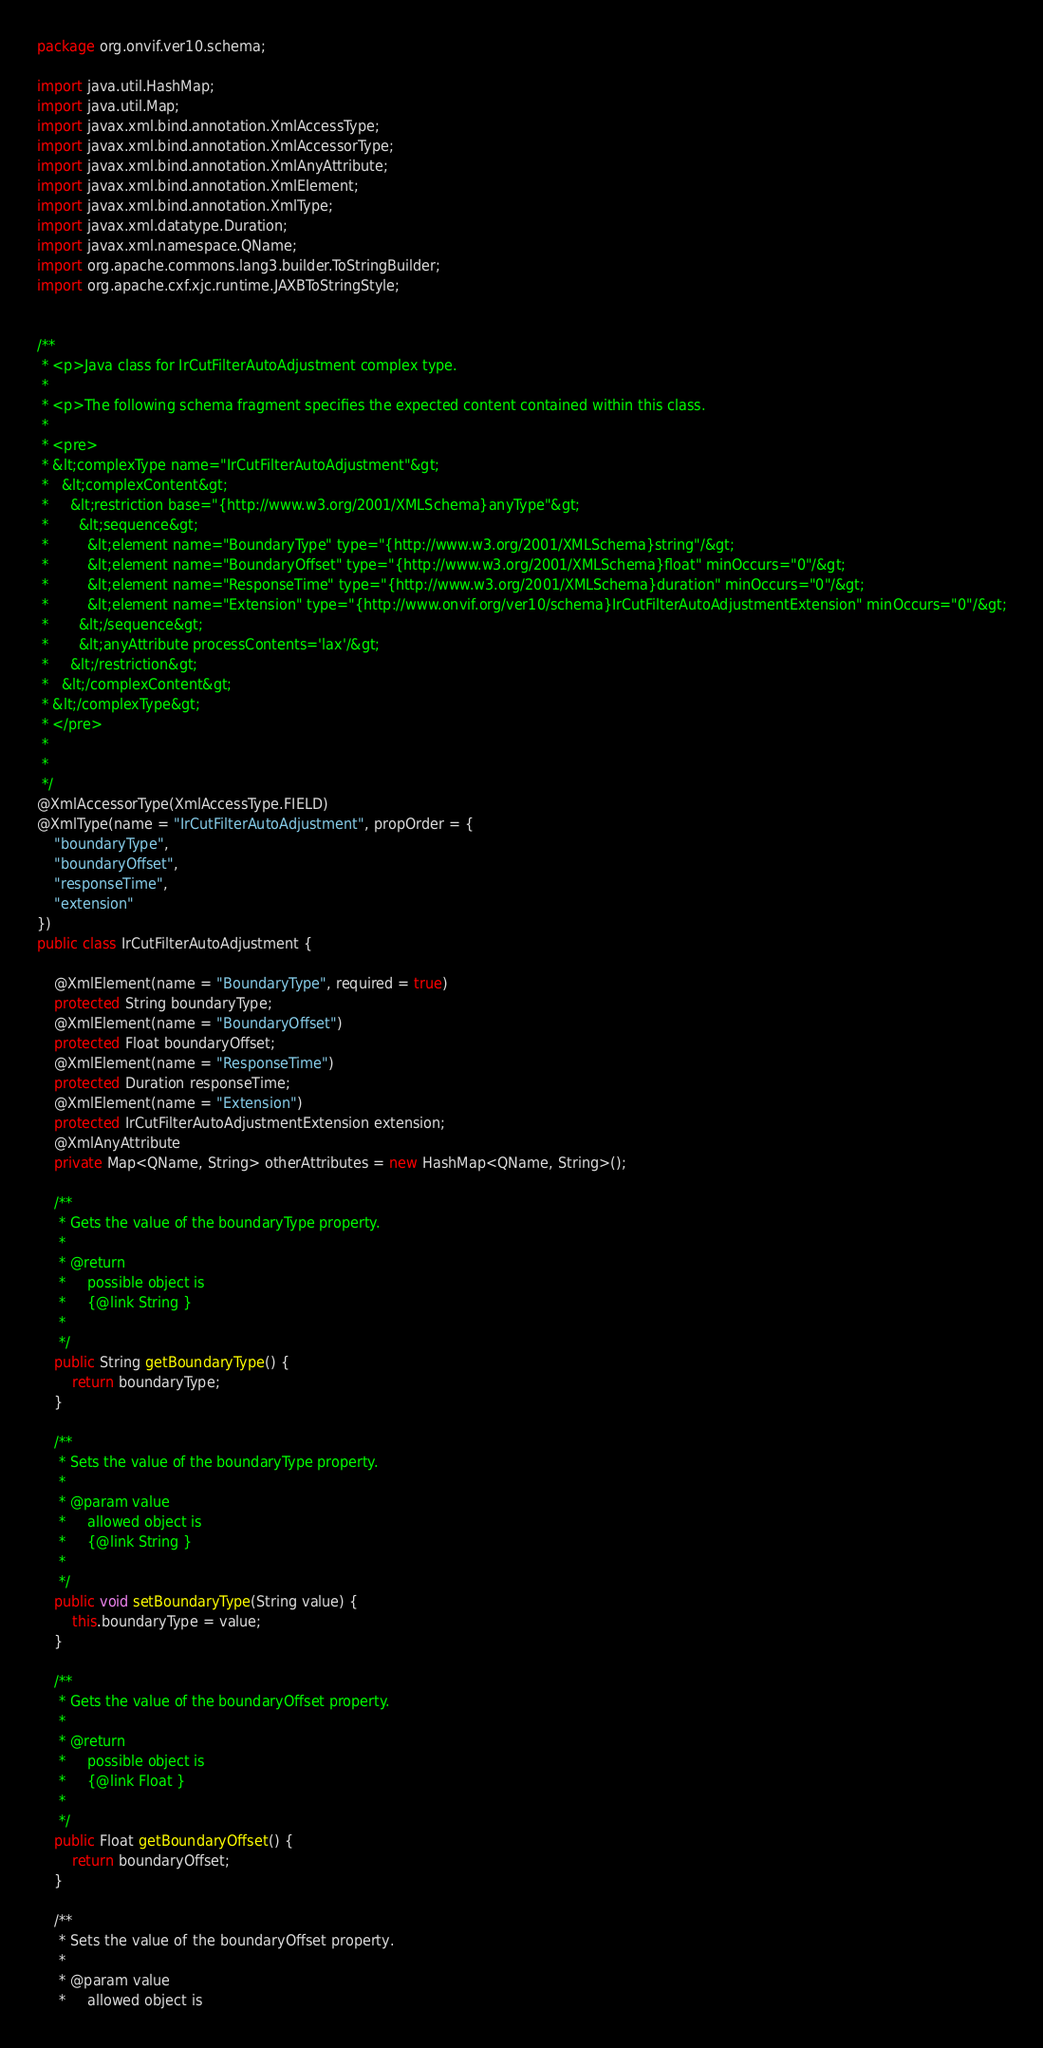<code> <loc_0><loc_0><loc_500><loc_500><_Java_>
package org.onvif.ver10.schema;

import java.util.HashMap;
import java.util.Map;
import javax.xml.bind.annotation.XmlAccessType;
import javax.xml.bind.annotation.XmlAccessorType;
import javax.xml.bind.annotation.XmlAnyAttribute;
import javax.xml.bind.annotation.XmlElement;
import javax.xml.bind.annotation.XmlType;
import javax.xml.datatype.Duration;
import javax.xml.namespace.QName;
import org.apache.commons.lang3.builder.ToStringBuilder;
import org.apache.cxf.xjc.runtime.JAXBToStringStyle;


/**
 * <p>Java class for IrCutFilterAutoAdjustment complex type.
 * 
 * <p>The following schema fragment specifies the expected content contained within this class.
 * 
 * <pre>
 * &lt;complexType name="IrCutFilterAutoAdjustment"&gt;
 *   &lt;complexContent&gt;
 *     &lt;restriction base="{http://www.w3.org/2001/XMLSchema}anyType"&gt;
 *       &lt;sequence&gt;
 *         &lt;element name="BoundaryType" type="{http://www.w3.org/2001/XMLSchema}string"/&gt;
 *         &lt;element name="BoundaryOffset" type="{http://www.w3.org/2001/XMLSchema}float" minOccurs="0"/&gt;
 *         &lt;element name="ResponseTime" type="{http://www.w3.org/2001/XMLSchema}duration" minOccurs="0"/&gt;
 *         &lt;element name="Extension" type="{http://www.onvif.org/ver10/schema}IrCutFilterAutoAdjustmentExtension" minOccurs="0"/&gt;
 *       &lt;/sequence&gt;
 *       &lt;anyAttribute processContents='lax'/&gt;
 *     &lt;/restriction&gt;
 *   &lt;/complexContent&gt;
 * &lt;/complexType&gt;
 * </pre>
 * 
 * 
 */
@XmlAccessorType(XmlAccessType.FIELD)
@XmlType(name = "IrCutFilterAutoAdjustment", propOrder = {
    "boundaryType",
    "boundaryOffset",
    "responseTime",
    "extension"
})
public class IrCutFilterAutoAdjustment {

    @XmlElement(name = "BoundaryType", required = true)
    protected String boundaryType;
    @XmlElement(name = "BoundaryOffset")
    protected Float boundaryOffset;
    @XmlElement(name = "ResponseTime")
    protected Duration responseTime;
    @XmlElement(name = "Extension")
    protected IrCutFilterAutoAdjustmentExtension extension;
    @XmlAnyAttribute
    private Map<QName, String> otherAttributes = new HashMap<QName, String>();

    /**
     * Gets the value of the boundaryType property.
     * 
     * @return
     *     possible object is
     *     {@link String }
     *     
     */
    public String getBoundaryType() {
        return boundaryType;
    }

    /**
     * Sets the value of the boundaryType property.
     * 
     * @param value
     *     allowed object is
     *     {@link String }
     *     
     */
    public void setBoundaryType(String value) {
        this.boundaryType = value;
    }

    /**
     * Gets the value of the boundaryOffset property.
     * 
     * @return
     *     possible object is
     *     {@link Float }
     *     
     */
    public Float getBoundaryOffset() {
        return boundaryOffset;
    }

    /**
     * Sets the value of the boundaryOffset property.
     * 
     * @param value
     *     allowed object is</code> 